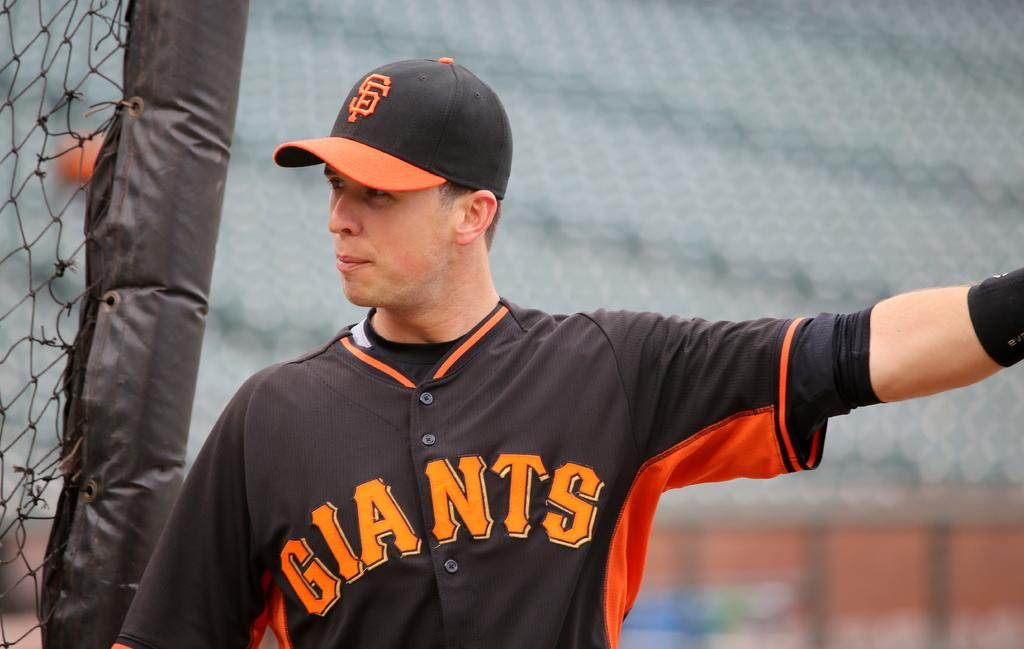<image>
Relay a brief, clear account of the picture shown. A baseball player is wearing a black and orange jersey that says Giants. 